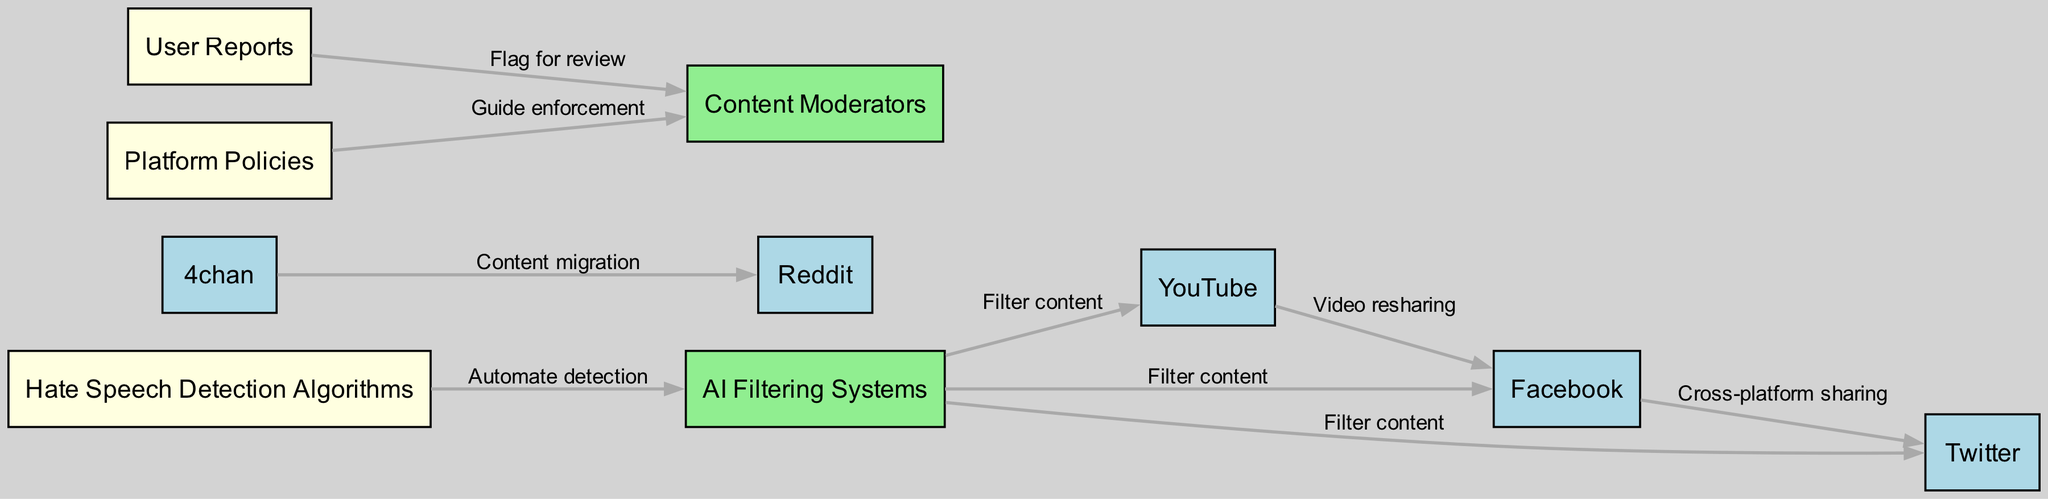What platforms are connected by the edge labeled "Cross-platform sharing"? The edge labeled "Cross-platform sharing" connects Facebook and Twitter. This can be identified by looking at the labeled edges in the directed graph and locating the specific label.
Answer: Facebook, Twitter How many nodes are displayed in the diagram? By counting the items listed under the "nodes" section in the data provided, we find a total of 10 distinct nodes.
Answer: 10 Which platform has the most connections in this diagram? By examining the edges, we see that AI Filtering Systems is connected to multiple social media platforms (Facebook, Twitter, YouTube) and is involved in content filtering. This analysis reveals it has three outgoing connections.
Answer: AI Filtering Systems What role does "User Reports" play in the detection of hate speech? The "User Reports" node points to "Content Moderators," indicating that user reports serve to flag potential instances of hate speech for review. This connection illustrates the flow of information from users to moderators.
Answer: Flag for review What is the relationship between "Hate Speech Detection Algorithms" and "AI Filtering Systems"? The edge labeled "Automate detection" connects these two nodes, indicating that hate speech detection algorithms contribute to the automation of filtering processes in AI systems. This demonstrates a direct link in how detection leads to filtering capabilities.
Answer: Automate detection Which two platforms are involved in content migration as indicated in the edges? The edge labeled "Content migration" connects 4chan to Reddit, indicating that content moves from the former to the latter. This relationship highlights a specific flow of content from one platform to another, allowing for the migration of hate speech.
Answer: 4chan, Reddit What is the purpose of "Platform Policies" in relation to "Content Moderators"? The edge labeled "Guide enforcement" shows that platform policies direct the actions of content moderators, indicating that these policies outline how moderation should be conducted. This highlights the governance aspect in the moderation process.
Answer: Guide enforcement How many platforms are filtered by "AI Filtering Systems"? "AI Filtering Systems" has outgoing edges to three platforms (Facebook, Twitter, and YouTube), indicating that it filters content for each of these social media services. This count of connections provides a clear answer to the query.
Answer: 3 